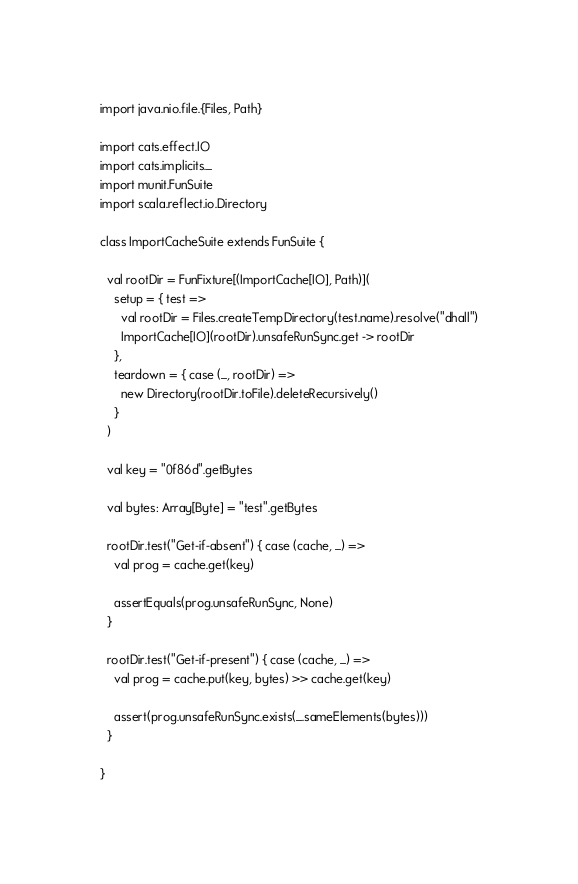Convert code to text. <code><loc_0><loc_0><loc_500><loc_500><_Scala_>
import java.nio.file.{Files, Path}

import cats.effect.IO
import cats.implicits._
import munit.FunSuite
import scala.reflect.io.Directory

class ImportCacheSuite extends FunSuite {

  val rootDir = FunFixture[(ImportCache[IO], Path)](
    setup = { test =>
      val rootDir = Files.createTempDirectory(test.name).resolve("dhall")
      ImportCache[IO](rootDir).unsafeRunSync.get -> rootDir
    },
    teardown = { case (_, rootDir) =>
      new Directory(rootDir.toFile).deleteRecursively()
    }
  )

  val key = "0f86d".getBytes

  val bytes: Array[Byte] = "test".getBytes

  rootDir.test("Get-if-absent") { case (cache, _) =>
    val prog = cache.get(key)

    assertEquals(prog.unsafeRunSync, None)
  }

  rootDir.test("Get-if-present") { case (cache, _) =>
    val prog = cache.put(key, bytes) >> cache.get(key)

    assert(prog.unsafeRunSync.exists(_.sameElements(bytes)))
  }

}
</code> 